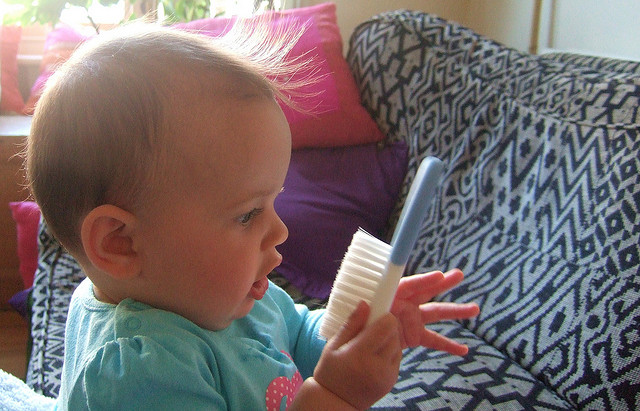What can parents learn from the baby's behavior in this image? From observing the baby in the image, parents can glean insights into their child's developmental milestones. The baby's intent focus and touch exploration of the hairbrush signify a burgeoning curiosity and sensory exploration, crucial at this developmental stage. This moment can teach parents the importance of presenting their children with safe, varied stimuli, which can aid in fine motor skills and cognitive development. Additionally, this scenario offers a teaching moment for parents to gently introduce concepts of daily routines, such as brushing one's hair, thereby utilizing everyday activities as educational experiences. 